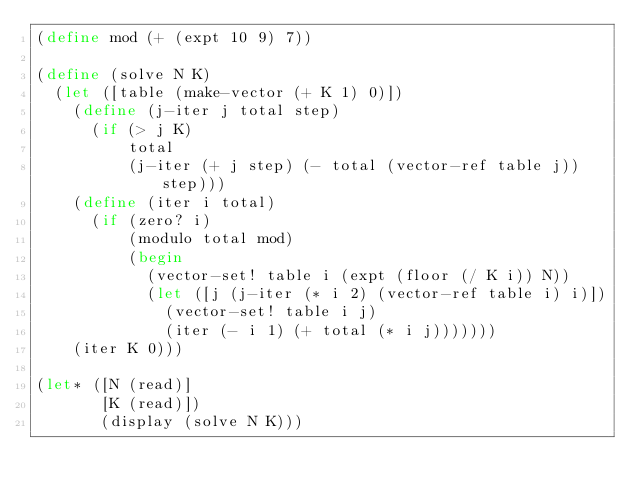Convert code to text. <code><loc_0><loc_0><loc_500><loc_500><_Scheme_>(define mod (+ (expt 10 9) 7))

(define (solve N K)
  (let ([table (make-vector (+ K 1) 0)])
    (define (j-iter j total step)
      (if (> j K)
          total
          (j-iter (+ j step) (- total (vector-ref table j)) step)))
    (define (iter i total)
      (if (zero? i)
          (modulo total mod)
          (begin
            (vector-set! table i (expt (floor (/ K i)) N))
            (let ([j (j-iter (* i 2) (vector-ref table i) i)])
              (vector-set! table i j)
              (iter (- i 1) (+ total (* i j)))))))
    (iter K 0)))

(let* ([N (read)]
       [K (read)])
       (display (solve N K)))</code> 